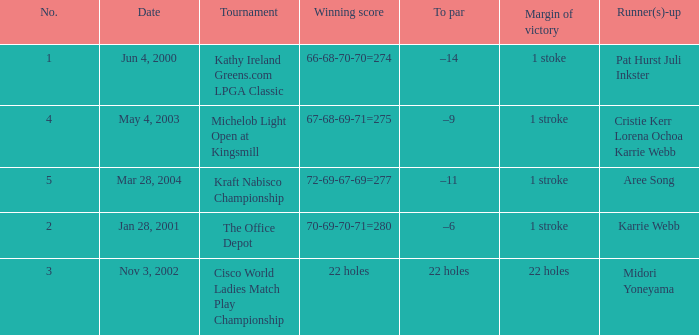What is the to par dated may 4, 2003? –9. 